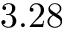<formula> <loc_0><loc_0><loc_500><loc_500>3 . 2 8</formula> 